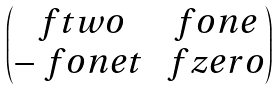<formula> <loc_0><loc_0><loc_500><loc_500>\begin{pmatrix} \ f t w o & \ f o n e \\ - \ f o n e t & \ f z e r o \end{pmatrix}</formula> 